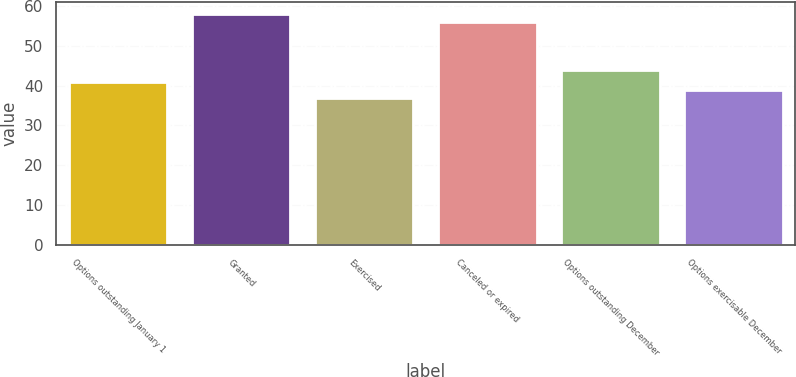Convert chart. <chart><loc_0><loc_0><loc_500><loc_500><bar_chart><fcel>Options outstanding January 1<fcel>Granted<fcel>Exercised<fcel>Canceled or expired<fcel>Options outstanding December<fcel>Options exercisable December<nl><fcel>41<fcel>58<fcel>37<fcel>56<fcel>44<fcel>39<nl></chart> 